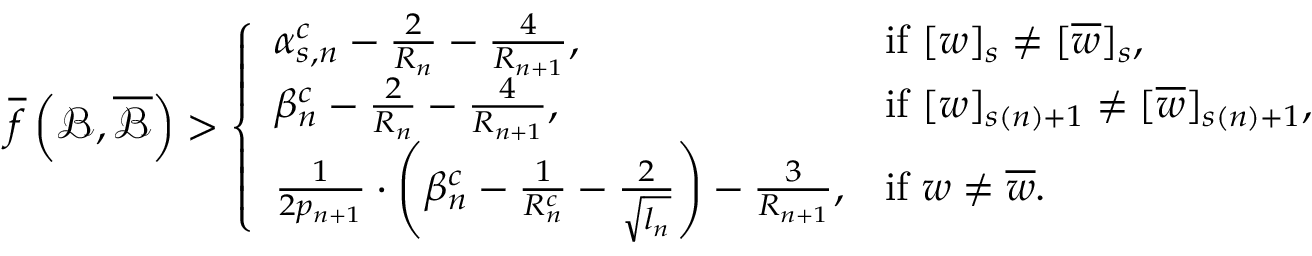Convert formula to latex. <formula><loc_0><loc_0><loc_500><loc_500>\overline { f } \left ( \mathcal { B } , \overline { { \mathcal { B } } } \right ) > \left \{ \begin{array} { l l } { \alpha _ { s , n } ^ { c } - \frac { 2 } { R _ { n } } - \frac { 4 } { R _ { n + 1 } } , } & { i f [ w ] _ { s } \neq [ \overline { w } ] _ { s } , } \\ { \beta _ { n } ^ { c } - \frac { 2 } { R _ { n } } - \frac { 4 } { R _ { n + 1 } } , } & { i f [ w ] _ { s ( n ) + 1 } \neq [ \overline { w } ] _ { s ( n ) + 1 } , } \\ { \frac { 1 } { 2 p _ { n + 1 } } \cdot \left ( \beta _ { n } ^ { c } - \frac { 1 } { R _ { n } ^ { c } } - \frac { 2 } { \sqrt { l _ { n } } } \right ) - \frac { 3 } { R _ { n + 1 } } , } & { i f w \neq \overline { w } . } \end{array}</formula> 